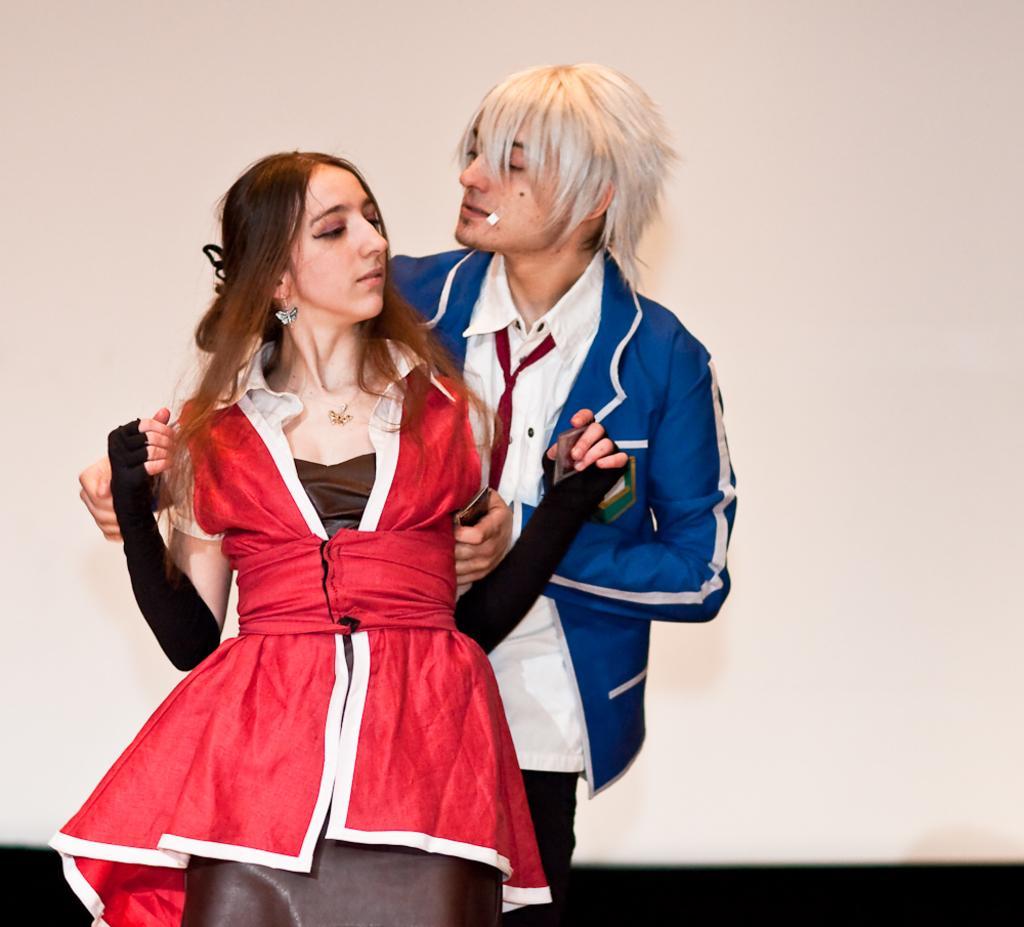Can you describe this image briefly? In this image I can see two people with red, brown, white and blue color dresses. And there is a white background. 